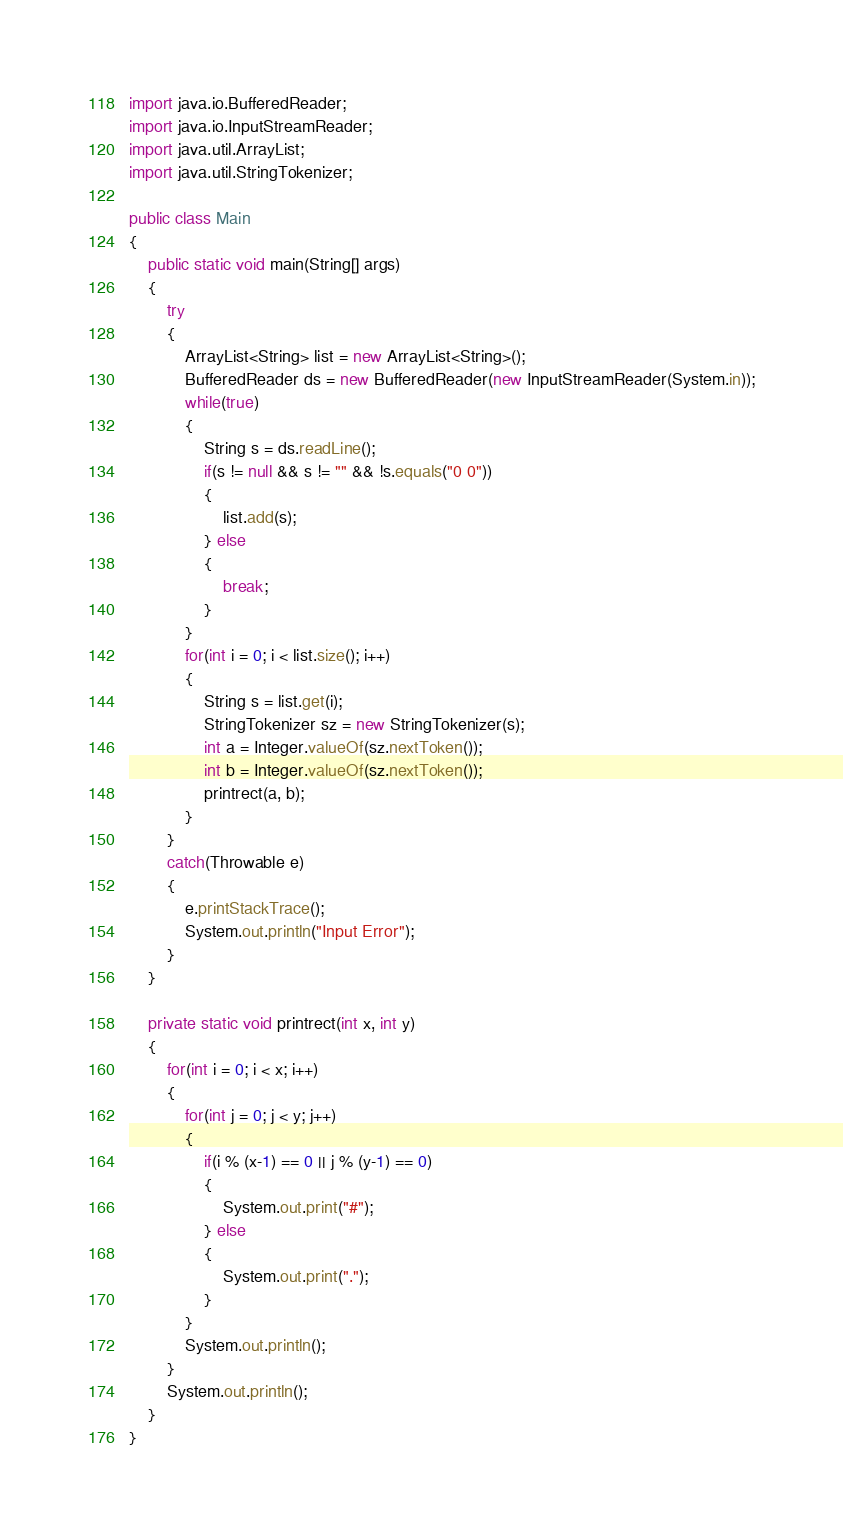Convert code to text. <code><loc_0><loc_0><loc_500><loc_500><_Java_>import java.io.BufferedReader;
import java.io.InputStreamReader;
import java.util.ArrayList;
import java.util.StringTokenizer;

public class Main
{
	public static void main(String[] args)
	{
		try
		{
			ArrayList<String> list = new ArrayList<String>();
			BufferedReader ds = new BufferedReader(new InputStreamReader(System.in));
			while(true)
			{
				String s = ds.readLine();
				if(s != null && s != "" && !s.equals("0 0"))
				{
					list.add(s);
				} else
				{
					break;
				}
			}
			for(int i = 0; i < list.size(); i++)
			{
				String s = list.get(i);
				StringTokenizer sz = new StringTokenizer(s);
				int a = Integer.valueOf(sz.nextToken());
				int b = Integer.valueOf(sz.nextToken());
				printrect(a, b);
			}
		}
		catch(Throwable e)
		{
			e.printStackTrace();
			System.out.println("Input Error");
		}
	}

	private static void printrect(int x, int y)
	{
		for(int i = 0; i < x; i++)
		{
			for(int j = 0; j < y; j++)
			{
				if(i % (x-1) == 0 || j % (y-1) == 0)
				{
					System.out.print("#");
				} else
				{
					System.out.print(".");
				}
			}
			System.out.println();
		}
		System.out.println();
	}
}</code> 